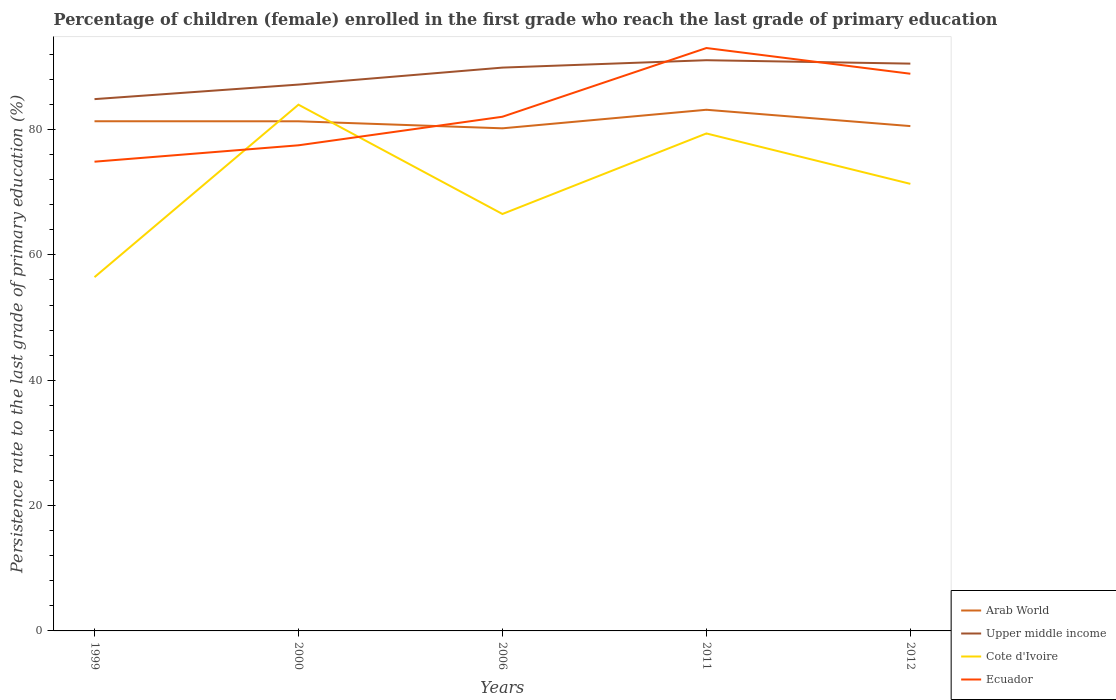How many different coloured lines are there?
Offer a terse response. 4. Does the line corresponding to Ecuador intersect with the line corresponding to Upper middle income?
Give a very brief answer. Yes. Is the number of lines equal to the number of legend labels?
Your answer should be very brief. Yes. Across all years, what is the maximum persistence rate of children in Arab World?
Give a very brief answer. 80.2. What is the total persistence rate of children in Cote d'Ivoire in the graph?
Your response must be concise. -14.88. What is the difference between the highest and the second highest persistence rate of children in Cote d'Ivoire?
Provide a short and direct response. 27.52. What is the difference between the highest and the lowest persistence rate of children in Ecuador?
Provide a short and direct response. 2. Is the persistence rate of children in Ecuador strictly greater than the persistence rate of children in Upper middle income over the years?
Keep it short and to the point. No. How many years are there in the graph?
Make the answer very short. 5. What is the difference between two consecutive major ticks on the Y-axis?
Offer a very short reply. 20. Are the values on the major ticks of Y-axis written in scientific E-notation?
Your answer should be compact. No. Does the graph contain grids?
Your answer should be compact. No. Where does the legend appear in the graph?
Give a very brief answer. Bottom right. What is the title of the graph?
Offer a very short reply. Percentage of children (female) enrolled in the first grade who reach the last grade of primary education. Does "Vietnam" appear as one of the legend labels in the graph?
Your answer should be compact. No. What is the label or title of the Y-axis?
Offer a terse response. Persistence rate to the last grade of primary education (%). What is the Persistence rate to the last grade of primary education (%) in Arab World in 1999?
Give a very brief answer. 81.32. What is the Persistence rate to the last grade of primary education (%) of Upper middle income in 1999?
Provide a short and direct response. 84.86. What is the Persistence rate to the last grade of primary education (%) in Cote d'Ivoire in 1999?
Offer a terse response. 56.45. What is the Persistence rate to the last grade of primary education (%) of Ecuador in 1999?
Ensure brevity in your answer.  74.87. What is the Persistence rate to the last grade of primary education (%) of Arab World in 2000?
Provide a short and direct response. 81.32. What is the Persistence rate to the last grade of primary education (%) in Upper middle income in 2000?
Your answer should be compact. 87.18. What is the Persistence rate to the last grade of primary education (%) in Cote d'Ivoire in 2000?
Keep it short and to the point. 83.97. What is the Persistence rate to the last grade of primary education (%) of Ecuador in 2000?
Provide a succinct answer. 77.49. What is the Persistence rate to the last grade of primary education (%) in Arab World in 2006?
Offer a very short reply. 80.2. What is the Persistence rate to the last grade of primary education (%) of Upper middle income in 2006?
Keep it short and to the point. 89.88. What is the Persistence rate to the last grade of primary education (%) in Cote d'Ivoire in 2006?
Provide a short and direct response. 66.53. What is the Persistence rate to the last grade of primary education (%) in Ecuador in 2006?
Give a very brief answer. 82.04. What is the Persistence rate to the last grade of primary education (%) in Arab World in 2011?
Give a very brief answer. 83.16. What is the Persistence rate to the last grade of primary education (%) of Upper middle income in 2011?
Offer a terse response. 91.06. What is the Persistence rate to the last grade of primary education (%) of Cote d'Ivoire in 2011?
Provide a short and direct response. 79.38. What is the Persistence rate to the last grade of primary education (%) of Ecuador in 2011?
Provide a succinct answer. 93.01. What is the Persistence rate to the last grade of primary education (%) of Arab World in 2012?
Your answer should be compact. 80.55. What is the Persistence rate to the last grade of primary education (%) of Upper middle income in 2012?
Offer a very short reply. 90.52. What is the Persistence rate to the last grade of primary education (%) of Cote d'Ivoire in 2012?
Ensure brevity in your answer.  71.33. What is the Persistence rate to the last grade of primary education (%) of Ecuador in 2012?
Your answer should be very brief. 88.91. Across all years, what is the maximum Persistence rate to the last grade of primary education (%) of Arab World?
Keep it short and to the point. 83.16. Across all years, what is the maximum Persistence rate to the last grade of primary education (%) in Upper middle income?
Provide a succinct answer. 91.06. Across all years, what is the maximum Persistence rate to the last grade of primary education (%) in Cote d'Ivoire?
Your answer should be very brief. 83.97. Across all years, what is the maximum Persistence rate to the last grade of primary education (%) in Ecuador?
Offer a terse response. 93.01. Across all years, what is the minimum Persistence rate to the last grade of primary education (%) of Arab World?
Your answer should be very brief. 80.2. Across all years, what is the minimum Persistence rate to the last grade of primary education (%) in Upper middle income?
Your answer should be compact. 84.86. Across all years, what is the minimum Persistence rate to the last grade of primary education (%) in Cote d'Ivoire?
Make the answer very short. 56.45. Across all years, what is the minimum Persistence rate to the last grade of primary education (%) of Ecuador?
Your answer should be very brief. 74.87. What is the total Persistence rate to the last grade of primary education (%) of Arab World in the graph?
Offer a terse response. 406.55. What is the total Persistence rate to the last grade of primary education (%) in Upper middle income in the graph?
Provide a short and direct response. 443.5. What is the total Persistence rate to the last grade of primary education (%) of Cote d'Ivoire in the graph?
Your answer should be compact. 357.65. What is the total Persistence rate to the last grade of primary education (%) of Ecuador in the graph?
Your response must be concise. 416.32. What is the difference between the Persistence rate to the last grade of primary education (%) of Arab World in 1999 and that in 2000?
Offer a very short reply. 0.01. What is the difference between the Persistence rate to the last grade of primary education (%) in Upper middle income in 1999 and that in 2000?
Give a very brief answer. -2.32. What is the difference between the Persistence rate to the last grade of primary education (%) of Cote d'Ivoire in 1999 and that in 2000?
Provide a succinct answer. -27.52. What is the difference between the Persistence rate to the last grade of primary education (%) in Ecuador in 1999 and that in 2000?
Ensure brevity in your answer.  -2.62. What is the difference between the Persistence rate to the last grade of primary education (%) in Arab World in 1999 and that in 2006?
Your answer should be very brief. 1.13. What is the difference between the Persistence rate to the last grade of primary education (%) of Upper middle income in 1999 and that in 2006?
Provide a short and direct response. -5.03. What is the difference between the Persistence rate to the last grade of primary education (%) of Cote d'Ivoire in 1999 and that in 2006?
Provide a succinct answer. -10.08. What is the difference between the Persistence rate to the last grade of primary education (%) of Ecuador in 1999 and that in 2006?
Offer a very short reply. -7.17. What is the difference between the Persistence rate to the last grade of primary education (%) in Arab World in 1999 and that in 2011?
Give a very brief answer. -1.83. What is the difference between the Persistence rate to the last grade of primary education (%) of Upper middle income in 1999 and that in 2011?
Ensure brevity in your answer.  -6.21. What is the difference between the Persistence rate to the last grade of primary education (%) in Cote d'Ivoire in 1999 and that in 2011?
Provide a short and direct response. -22.93. What is the difference between the Persistence rate to the last grade of primary education (%) of Ecuador in 1999 and that in 2011?
Keep it short and to the point. -18.14. What is the difference between the Persistence rate to the last grade of primary education (%) of Arab World in 1999 and that in 2012?
Keep it short and to the point. 0.77. What is the difference between the Persistence rate to the last grade of primary education (%) of Upper middle income in 1999 and that in 2012?
Your answer should be very brief. -5.66. What is the difference between the Persistence rate to the last grade of primary education (%) in Cote d'Ivoire in 1999 and that in 2012?
Provide a short and direct response. -14.88. What is the difference between the Persistence rate to the last grade of primary education (%) of Ecuador in 1999 and that in 2012?
Make the answer very short. -14.03. What is the difference between the Persistence rate to the last grade of primary education (%) of Arab World in 2000 and that in 2006?
Offer a terse response. 1.12. What is the difference between the Persistence rate to the last grade of primary education (%) of Upper middle income in 2000 and that in 2006?
Make the answer very short. -2.71. What is the difference between the Persistence rate to the last grade of primary education (%) in Cote d'Ivoire in 2000 and that in 2006?
Keep it short and to the point. 17.44. What is the difference between the Persistence rate to the last grade of primary education (%) in Ecuador in 2000 and that in 2006?
Offer a very short reply. -4.56. What is the difference between the Persistence rate to the last grade of primary education (%) of Arab World in 2000 and that in 2011?
Provide a succinct answer. -1.84. What is the difference between the Persistence rate to the last grade of primary education (%) of Upper middle income in 2000 and that in 2011?
Your response must be concise. -3.89. What is the difference between the Persistence rate to the last grade of primary education (%) of Cote d'Ivoire in 2000 and that in 2011?
Your answer should be compact. 4.59. What is the difference between the Persistence rate to the last grade of primary education (%) of Ecuador in 2000 and that in 2011?
Provide a short and direct response. -15.52. What is the difference between the Persistence rate to the last grade of primary education (%) of Arab World in 2000 and that in 2012?
Keep it short and to the point. 0.76. What is the difference between the Persistence rate to the last grade of primary education (%) in Upper middle income in 2000 and that in 2012?
Provide a succinct answer. -3.34. What is the difference between the Persistence rate to the last grade of primary education (%) of Cote d'Ivoire in 2000 and that in 2012?
Provide a succinct answer. 12.64. What is the difference between the Persistence rate to the last grade of primary education (%) in Ecuador in 2000 and that in 2012?
Your answer should be very brief. -11.42. What is the difference between the Persistence rate to the last grade of primary education (%) in Arab World in 2006 and that in 2011?
Provide a short and direct response. -2.96. What is the difference between the Persistence rate to the last grade of primary education (%) of Upper middle income in 2006 and that in 2011?
Your answer should be very brief. -1.18. What is the difference between the Persistence rate to the last grade of primary education (%) in Cote d'Ivoire in 2006 and that in 2011?
Your answer should be compact. -12.85. What is the difference between the Persistence rate to the last grade of primary education (%) of Ecuador in 2006 and that in 2011?
Provide a succinct answer. -10.96. What is the difference between the Persistence rate to the last grade of primary education (%) of Arab World in 2006 and that in 2012?
Your answer should be very brief. -0.36. What is the difference between the Persistence rate to the last grade of primary education (%) in Upper middle income in 2006 and that in 2012?
Your answer should be very brief. -0.63. What is the difference between the Persistence rate to the last grade of primary education (%) in Cote d'Ivoire in 2006 and that in 2012?
Your answer should be compact. -4.81. What is the difference between the Persistence rate to the last grade of primary education (%) in Ecuador in 2006 and that in 2012?
Your response must be concise. -6.86. What is the difference between the Persistence rate to the last grade of primary education (%) in Arab World in 2011 and that in 2012?
Your response must be concise. 2.6. What is the difference between the Persistence rate to the last grade of primary education (%) in Upper middle income in 2011 and that in 2012?
Provide a short and direct response. 0.55. What is the difference between the Persistence rate to the last grade of primary education (%) of Cote d'Ivoire in 2011 and that in 2012?
Give a very brief answer. 8.04. What is the difference between the Persistence rate to the last grade of primary education (%) in Ecuador in 2011 and that in 2012?
Provide a short and direct response. 4.1. What is the difference between the Persistence rate to the last grade of primary education (%) of Arab World in 1999 and the Persistence rate to the last grade of primary education (%) of Upper middle income in 2000?
Keep it short and to the point. -5.85. What is the difference between the Persistence rate to the last grade of primary education (%) in Arab World in 1999 and the Persistence rate to the last grade of primary education (%) in Cote d'Ivoire in 2000?
Provide a succinct answer. -2.65. What is the difference between the Persistence rate to the last grade of primary education (%) in Arab World in 1999 and the Persistence rate to the last grade of primary education (%) in Ecuador in 2000?
Your answer should be compact. 3.84. What is the difference between the Persistence rate to the last grade of primary education (%) of Upper middle income in 1999 and the Persistence rate to the last grade of primary education (%) of Cote d'Ivoire in 2000?
Provide a succinct answer. 0.89. What is the difference between the Persistence rate to the last grade of primary education (%) in Upper middle income in 1999 and the Persistence rate to the last grade of primary education (%) in Ecuador in 2000?
Your answer should be compact. 7.37. What is the difference between the Persistence rate to the last grade of primary education (%) in Cote d'Ivoire in 1999 and the Persistence rate to the last grade of primary education (%) in Ecuador in 2000?
Your answer should be compact. -21.04. What is the difference between the Persistence rate to the last grade of primary education (%) of Arab World in 1999 and the Persistence rate to the last grade of primary education (%) of Upper middle income in 2006?
Make the answer very short. -8.56. What is the difference between the Persistence rate to the last grade of primary education (%) of Arab World in 1999 and the Persistence rate to the last grade of primary education (%) of Cote d'Ivoire in 2006?
Provide a succinct answer. 14.8. What is the difference between the Persistence rate to the last grade of primary education (%) in Arab World in 1999 and the Persistence rate to the last grade of primary education (%) in Ecuador in 2006?
Ensure brevity in your answer.  -0.72. What is the difference between the Persistence rate to the last grade of primary education (%) in Upper middle income in 1999 and the Persistence rate to the last grade of primary education (%) in Cote d'Ivoire in 2006?
Ensure brevity in your answer.  18.33. What is the difference between the Persistence rate to the last grade of primary education (%) in Upper middle income in 1999 and the Persistence rate to the last grade of primary education (%) in Ecuador in 2006?
Your response must be concise. 2.81. What is the difference between the Persistence rate to the last grade of primary education (%) in Cote d'Ivoire in 1999 and the Persistence rate to the last grade of primary education (%) in Ecuador in 2006?
Offer a very short reply. -25.59. What is the difference between the Persistence rate to the last grade of primary education (%) in Arab World in 1999 and the Persistence rate to the last grade of primary education (%) in Upper middle income in 2011?
Offer a very short reply. -9.74. What is the difference between the Persistence rate to the last grade of primary education (%) of Arab World in 1999 and the Persistence rate to the last grade of primary education (%) of Cote d'Ivoire in 2011?
Offer a terse response. 1.95. What is the difference between the Persistence rate to the last grade of primary education (%) in Arab World in 1999 and the Persistence rate to the last grade of primary education (%) in Ecuador in 2011?
Ensure brevity in your answer.  -11.68. What is the difference between the Persistence rate to the last grade of primary education (%) of Upper middle income in 1999 and the Persistence rate to the last grade of primary education (%) of Cote d'Ivoire in 2011?
Your answer should be compact. 5.48. What is the difference between the Persistence rate to the last grade of primary education (%) in Upper middle income in 1999 and the Persistence rate to the last grade of primary education (%) in Ecuador in 2011?
Make the answer very short. -8.15. What is the difference between the Persistence rate to the last grade of primary education (%) of Cote d'Ivoire in 1999 and the Persistence rate to the last grade of primary education (%) of Ecuador in 2011?
Keep it short and to the point. -36.56. What is the difference between the Persistence rate to the last grade of primary education (%) of Arab World in 1999 and the Persistence rate to the last grade of primary education (%) of Upper middle income in 2012?
Provide a succinct answer. -9.19. What is the difference between the Persistence rate to the last grade of primary education (%) of Arab World in 1999 and the Persistence rate to the last grade of primary education (%) of Cote d'Ivoire in 2012?
Offer a terse response. 9.99. What is the difference between the Persistence rate to the last grade of primary education (%) of Arab World in 1999 and the Persistence rate to the last grade of primary education (%) of Ecuador in 2012?
Your answer should be very brief. -7.58. What is the difference between the Persistence rate to the last grade of primary education (%) of Upper middle income in 1999 and the Persistence rate to the last grade of primary education (%) of Cote d'Ivoire in 2012?
Offer a terse response. 13.52. What is the difference between the Persistence rate to the last grade of primary education (%) of Upper middle income in 1999 and the Persistence rate to the last grade of primary education (%) of Ecuador in 2012?
Provide a succinct answer. -4.05. What is the difference between the Persistence rate to the last grade of primary education (%) of Cote d'Ivoire in 1999 and the Persistence rate to the last grade of primary education (%) of Ecuador in 2012?
Offer a very short reply. -32.46. What is the difference between the Persistence rate to the last grade of primary education (%) in Arab World in 2000 and the Persistence rate to the last grade of primary education (%) in Upper middle income in 2006?
Your answer should be compact. -8.57. What is the difference between the Persistence rate to the last grade of primary education (%) in Arab World in 2000 and the Persistence rate to the last grade of primary education (%) in Cote d'Ivoire in 2006?
Your answer should be very brief. 14.79. What is the difference between the Persistence rate to the last grade of primary education (%) of Arab World in 2000 and the Persistence rate to the last grade of primary education (%) of Ecuador in 2006?
Make the answer very short. -0.73. What is the difference between the Persistence rate to the last grade of primary education (%) in Upper middle income in 2000 and the Persistence rate to the last grade of primary education (%) in Cote d'Ivoire in 2006?
Offer a terse response. 20.65. What is the difference between the Persistence rate to the last grade of primary education (%) in Upper middle income in 2000 and the Persistence rate to the last grade of primary education (%) in Ecuador in 2006?
Ensure brevity in your answer.  5.13. What is the difference between the Persistence rate to the last grade of primary education (%) in Cote d'Ivoire in 2000 and the Persistence rate to the last grade of primary education (%) in Ecuador in 2006?
Your answer should be compact. 1.93. What is the difference between the Persistence rate to the last grade of primary education (%) in Arab World in 2000 and the Persistence rate to the last grade of primary education (%) in Upper middle income in 2011?
Your response must be concise. -9.75. What is the difference between the Persistence rate to the last grade of primary education (%) of Arab World in 2000 and the Persistence rate to the last grade of primary education (%) of Cote d'Ivoire in 2011?
Provide a succinct answer. 1.94. What is the difference between the Persistence rate to the last grade of primary education (%) in Arab World in 2000 and the Persistence rate to the last grade of primary education (%) in Ecuador in 2011?
Make the answer very short. -11.69. What is the difference between the Persistence rate to the last grade of primary education (%) in Upper middle income in 2000 and the Persistence rate to the last grade of primary education (%) in Cote d'Ivoire in 2011?
Keep it short and to the point. 7.8. What is the difference between the Persistence rate to the last grade of primary education (%) in Upper middle income in 2000 and the Persistence rate to the last grade of primary education (%) in Ecuador in 2011?
Ensure brevity in your answer.  -5.83. What is the difference between the Persistence rate to the last grade of primary education (%) in Cote d'Ivoire in 2000 and the Persistence rate to the last grade of primary education (%) in Ecuador in 2011?
Offer a very short reply. -9.04. What is the difference between the Persistence rate to the last grade of primary education (%) of Arab World in 2000 and the Persistence rate to the last grade of primary education (%) of Upper middle income in 2012?
Make the answer very short. -9.2. What is the difference between the Persistence rate to the last grade of primary education (%) in Arab World in 2000 and the Persistence rate to the last grade of primary education (%) in Cote d'Ivoire in 2012?
Make the answer very short. 9.98. What is the difference between the Persistence rate to the last grade of primary education (%) in Arab World in 2000 and the Persistence rate to the last grade of primary education (%) in Ecuador in 2012?
Provide a succinct answer. -7.59. What is the difference between the Persistence rate to the last grade of primary education (%) in Upper middle income in 2000 and the Persistence rate to the last grade of primary education (%) in Cote d'Ivoire in 2012?
Offer a terse response. 15.84. What is the difference between the Persistence rate to the last grade of primary education (%) of Upper middle income in 2000 and the Persistence rate to the last grade of primary education (%) of Ecuador in 2012?
Give a very brief answer. -1.73. What is the difference between the Persistence rate to the last grade of primary education (%) in Cote d'Ivoire in 2000 and the Persistence rate to the last grade of primary education (%) in Ecuador in 2012?
Your answer should be compact. -4.94. What is the difference between the Persistence rate to the last grade of primary education (%) in Arab World in 2006 and the Persistence rate to the last grade of primary education (%) in Upper middle income in 2011?
Provide a short and direct response. -10.87. What is the difference between the Persistence rate to the last grade of primary education (%) of Arab World in 2006 and the Persistence rate to the last grade of primary education (%) of Cote d'Ivoire in 2011?
Your answer should be compact. 0.82. What is the difference between the Persistence rate to the last grade of primary education (%) of Arab World in 2006 and the Persistence rate to the last grade of primary education (%) of Ecuador in 2011?
Offer a terse response. -12.81. What is the difference between the Persistence rate to the last grade of primary education (%) of Upper middle income in 2006 and the Persistence rate to the last grade of primary education (%) of Cote d'Ivoire in 2011?
Provide a short and direct response. 10.51. What is the difference between the Persistence rate to the last grade of primary education (%) of Upper middle income in 2006 and the Persistence rate to the last grade of primary education (%) of Ecuador in 2011?
Provide a succinct answer. -3.12. What is the difference between the Persistence rate to the last grade of primary education (%) in Cote d'Ivoire in 2006 and the Persistence rate to the last grade of primary education (%) in Ecuador in 2011?
Give a very brief answer. -26.48. What is the difference between the Persistence rate to the last grade of primary education (%) of Arab World in 2006 and the Persistence rate to the last grade of primary education (%) of Upper middle income in 2012?
Offer a very short reply. -10.32. What is the difference between the Persistence rate to the last grade of primary education (%) of Arab World in 2006 and the Persistence rate to the last grade of primary education (%) of Cote d'Ivoire in 2012?
Your response must be concise. 8.86. What is the difference between the Persistence rate to the last grade of primary education (%) of Arab World in 2006 and the Persistence rate to the last grade of primary education (%) of Ecuador in 2012?
Provide a short and direct response. -8.71. What is the difference between the Persistence rate to the last grade of primary education (%) of Upper middle income in 2006 and the Persistence rate to the last grade of primary education (%) of Cote d'Ivoire in 2012?
Ensure brevity in your answer.  18.55. What is the difference between the Persistence rate to the last grade of primary education (%) of Upper middle income in 2006 and the Persistence rate to the last grade of primary education (%) of Ecuador in 2012?
Your answer should be compact. 0.98. What is the difference between the Persistence rate to the last grade of primary education (%) in Cote d'Ivoire in 2006 and the Persistence rate to the last grade of primary education (%) in Ecuador in 2012?
Give a very brief answer. -22.38. What is the difference between the Persistence rate to the last grade of primary education (%) of Arab World in 2011 and the Persistence rate to the last grade of primary education (%) of Upper middle income in 2012?
Keep it short and to the point. -7.36. What is the difference between the Persistence rate to the last grade of primary education (%) of Arab World in 2011 and the Persistence rate to the last grade of primary education (%) of Cote d'Ivoire in 2012?
Your answer should be very brief. 11.82. What is the difference between the Persistence rate to the last grade of primary education (%) in Arab World in 2011 and the Persistence rate to the last grade of primary education (%) in Ecuador in 2012?
Give a very brief answer. -5.75. What is the difference between the Persistence rate to the last grade of primary education (%) in Upper middle income in 2011 and the Persistence rate to the last grade of primary education (%) in Cote d'Ivoire in 2012?
Offer a very short reply. 19.73. What is the difference between the Persistence rate to the last grade of primary education (%) in Upper middle income in 2011 and the Persistence rate to the last grade of primary education (%) in Ecuador in 2012?
Make the answer very short. 2.16. What is the difference between the Persistence rate to the last grade of primary education (%) in Cote d'Ivoire in 2011 and the Persistence rate to the last grade of primary education (%) in Ecuador in 2012?
Offer a very short reply. -9.53. What is the average Persistence rate to the last grade of primary education (%) of Arab World per year?
Offer a terse response. 81.31. What is the average Persistence rate to the last grade of primary education (%) of Upper middle income per year?
Your answer should be compact. 88.7. What is the average Persistence rate to the last grade of primary education (%) of Cote d'Ivoire per year?
Your answer should be compact. 71.53. What is the average Persistence rate to the last grade of primary education (%) in Ecuador per year?
Keep it short and to the point. 83.26. In the year 1999, what is the difference between the Persistence rate to the last grade of primary education (%) in Arab World and Persistence rate to the last grade of primary education (%) in Upper middle income?
Your answer should be very brief. -3.53. In the year 1999, what is the difference between the Persistence rate to the last grade of primary education (%) in Arab World and Persistence rate to the last grade of primary education (%) in Cote d'Ivoire?
Provide a short and direct response. 24.87. In the year 1999, what is the difference between the Persistence rate to the last grade of primary education (%) in Arab World and Persistence rate to the last grade of primary education (%) in Ecuador?
Your response must be concise. 6.45. In the year 1999, what is the difference between the Persistence rate to the last grade of primary education (%) of Upper middle income and Persistence rate to the last grade of primary education (%) of Cote d'Ivoire?
Make the answer very short. 28.41. In the year 1999, what is the difference between the Persistence rate to the last grade of primary education (%) in Upper middle income and Persistence rate to the last grade of primary education (%) in Ecuador?
Your response must be concise. 9.98. In the year 1999, what is the difference between the Persistence rate to the last grade of primary education (%) in Cote d'Ivoire and Persistence rate to the last grade of primary education (%) in Ecuador?
Your answer should be compact. -18.42. In the year 2000, what is the difference between the Persistence rate to the last grade of primary education (%) of Arab World and Persistence rate to the last grade of primary education (%) of Upper middle income?
Your response must be concise. -5.86. In the year 2000, what is the difference between the Persistence rate to the last grade of primary education (%) in Arab World and Persistence rate to the last grade of primary education (%) in Cote d'Ivoire?
Your answer should be compact. -2.65. In the year 2000, what is the difference between the Persistence rate to the last grade of primary education (%) in Arab World and Persistence rate to the last grade of primary education (%) in Ecuador?
Offer a very short reply. 3.83. In the year 2000, what is the difference between the Persistence rate to the last grade of primary education (%) of Upper middle income and Persistence rate to the last grade of primary education (%) of Cote d'Ivoire?
Provide a short and direct response. 3.21. In the year 2000, what is the difference between the Persistence rate to the last grade of primary education (%) of Upper middle income and Persistence rate to the last grade of primary education (%) of Ecuador?
Your answer should be very brief. 9.69. In the year 2000, what is the difference between the Persistence rate to the last grade of primary education (%) of Cote d'Ivoire and Persistence rate to the last grade of primary education (%) of Ecuador?
Provide a succinct answer. 6.48. In the year 2006, what is the difference between the Persistence rate to the last grade of primary education (%) of Arab World and Persistence rate to the last grade of primary education (%) of Upper middle income?
Offer a very short reply. -9.69. In the year 2006, what is the difference between the Persistence rate to the last grade of primary education (%) of Arab World and Persistence rate to the last grade of primary education (%) of Cote d'Ivoire?
Provide a short and direct response. 13.67. In the year 2006, what is the difference between the Persistence rate to the last grade of primary education (%) in Arab World and Persistence rate to the last grade of primary education (%) in Ecuador?
Your answer should be very brief. -1.85. In the year 2006, what is the difference between the Persistence rate to the last grade of primary education (%) of Upper middle income and Persistence rate to the last grade of primary education (%) of Cote d'Ivoire?
Ensure brevity in your answer.  23.36. In the year 2006, what is the difference between the Persistence rate to the last grade of primary education (%) of Upper middle income and Persistence rate to the last grade of primary education (%) of Ecuador?
Make the answer very short. 7.84. In the year 2006, what is the difference between the Persistence rate to the last grade of primary education (%) of Cote d'Ivoire and Persistence rate to the last grade of primary education (%) of Ecuador?
Your response must be concise. -15.52. In the year 2011, what is the difference between the Persistence rate to the last grade of primary education (%) of Arab World and Persistence rate to the last grade of primary education (%) of Upper middle income?
Give a very brief answer. -7.91. In the year 2011, what is the difference between the Persistence rate to the last grade of primary education (%) of Arab World and Persistence rate to the last grade of primary education (%) of Cote d'Ivoire?
Ensure brevity in your answer.  3.78. In the year 2011, what is the difference between the Persistence rate to the last grade of primary education (%) of Arab World and Persistence rate to the last grade of primary education (%) of Ecuador?
Ensure brevity in your answer.  -9.85. In the year 2011, what is the difference between the Persistence rate to the last grade of primary education (%) in Upper middle income and Persistence rate to the last grade of primary education (%) in Cote d'Ivoire?
Your answer should be compact. 11.69. In the year 2011, what is the difference between the Persistence rate to the last grade of primary education (%) of Upper middle income and Persistence rate to the last grade of primary education (%) of Ecuador?
Your answer should be compact. -1.94. In the year 2011, what is the difference between the Persistence rate to the last grade of primary education (%) in Cote d'Ivoire and Persistence rate to the last grade of primary education (%) in Ecuador?
Offer a very short reply. -13.63. In the year 2012, what is the difference between the Persistence rate to the last grade of primary education (%) in Arab World and Persistence rate to the last grade of primary education (%) in Upper middle income?
Provide a succinct answer. -9.97. In the year 2012, what is the difference between the Persistence rate to the last grade of primary education (%) in Arab World and Persistence rate to the last grade of primary education (%) in Cote d'Ivoire?
Your answer should be compact. 9.22. In the year 2012, what is the difference between the Persistence rate to the last grade of primary education (%) of Arab World and Persistence rate to the last grade of primary education (%) of Ecuador?
Offer a very short reply. -8.35. In the year 2012, what is the difference between the Persistence rate to the last grade of primary education (%) in Upper middle income and Persistence rate to the last grade of primary education (%) in Cote d'Ivoire?
Keep it short and to the point. 19.18. In the year 2012, what is the difference between the Persistence rate to the last grade of primary education (%) of Upper middle income and Persistence rate to the last grade of primary education (%) of Ecuador?
Provide a short and direct response. 1.61. In the year 2012, what is the difference between the Persistence rate to the last grade of primary education (%) of Cote d'Ivoire and Persistence rate to the last grade of primary education (%) of Ecuador?
Provide a short and direct response. -17.57. What is the ratio of the Persistence rate to the last grade of primary education (%) of Upper middle income in 1999 to that in 2000?
Provide a short and direct response. 0.97. What is the ratio of the Persistence rate to the last grade of primary education (%) of Cote d'Ivoire in 1999 to that in 2000?
Your response must be concise. 0.67. What is the ratio of the Persistence rate to the last grade of primary education (%) of Ecuador in 1999 to that in 2000?
Your response must be concise. 0.97. What is the ratio of the Persistence rate to the last grade of primary education (%) in Arab World in 1999 to that in 2006?
Offer a terse response. 1.01. What is the ratio of the Persistence rate to the last grade of primary education (%) in Upper middle income in 1999 to that in 2006?
Provide a short and direct response. 0.94. What is the ratio of the Persistence rate to the last grade of primary education (%) in Cote d'Ivoire in 1999 to that in 2006?
Give a very brief answer. 0.85. What is the ratio of the Persistence rate to the last grade of primary education (%) in Ecuador in 1999 to that in 2006?
Provide a short and direct response. 0.91. What is the ratio of the Persistence rate to the last grade of primary education (%) in Arab World in 1999 to that in 2011?
Offer a terse response. 0.98. What is the ratio of the Persistence rate to the last grade of primary education (%) in Upper middle income in 1999 to that in 2011?
Give a very brief answer. 0.93. What is the ratio of the Persistence rate to the last grade of primary education (%) in Cote d'Ivoire in 1999 to that in 2011?
Ensure brevity in your answer.  0.71. What is the ratio of the Persistence rate to the last grade of primary education (%) in Ecuador in 1999 to that in 2011?
Your answer should be very brief. 0.81. What is the ratio of the Persistence rate to the last grade of primary education (%) of Arab World in 1999 to that in 2012?
Your answer should be compact. 1.01. What is the ratio of the Persistence rate to the last grade of primary education (%) of Upper middle income in 1999 to that in 2012?
Make the answer very short. 0.94. What is the ratio of the Persistence rate to the last grade of primary education (%) of Cote d'Ivoire in 1999 to that in 2012?
Provide a succinct answer. 0.79. What is the ratio of the Persistence rate to the last grade of primary education (%) in Ecuador in 1999 to that in 2012?
Give a very brief answer. 0.84. What is the ratio of the Persistence rate to the last grade of primary education (%) in Upper middle income in 2000 to that in 2006?
Offer a terse response. 0.97. What is the ratio of the Persistence rate to the last grade of primary education (%) of Cote d'Ivoire in 2000 to that in 2006?
Provide a short and direct response. 1.26. What is the ratio of the Persistence rate to the last grade of primary education (%) in Ecuador in 2000 to that in 2006?
Give a very brief answer. 0.94. What is the ratio of the Persistence rate to the last grade of primary education (%) in Arab World in 2000 to that in 2011?
Provide a succinct answer. 0.98. What is the ratio of the Persistence rate to the last grade of primary education (%) of Upper middle income in 2000 to that in 2011?
Give a very brief answer. 0.96. What is the ratio of the Persistence rate to the last grade of primary education (%) in Cote d'Ivoire in 2000 to that in 2011?
Offer a terse response. 1.06. What is the ratio of the Persistence rate to the last grade of primary education (%) of Ecuador in 2000 to that in 2011?
Your answer should be very brief. 0.83. What is the ratio of the Persistence rate to the last grade of primary education (%) of Arab World in 2000 to that in 2012?
Ensure brevity in your answer.  1.01. What is the ratio of the Persistence rate to the last grade of primary education (%) in Upper middle income in 2000 to that in 2012?
Keep it short and to the point. 0.96. What is the ratio of the Persistence rate to the last grade of primary education (%) of Cote d'Ivoire in 2000 to that in 2012?
Your answer should be compact. 1.18. What is the ratio of the Persistence rate to the last grade of primary education (%) of Ecuador in 2000 to that in 2012?
Offer a very short reply. 0.87. What is the ratio of the Persistence rate to the last grade of primary education (%) of Arab World in 2006 to that in 2011?
Your answer should be compact. 0.96. What is the ratio of the Persistence rate to the last grade of primary education (%) in Upper middle income in 2006 to that in 2011?
Offer a very short reply. 0.99. What is the ratio of the Persistence rate to the last grade of primary education (%) in Cote d'Ivoire in 2006 to that in 2011?
Provide a succinct answer. 0.84. What is the ratio of the Persistence rate to the last grade of primary education (%) in Ecuador in 2006 to that in 2011?
Provide a succinct answer. 0.88. What is the ratio of the Persistence rate to the last grade of primary education (%) in Upper middle income in 2006 to that in 2012?
Give a very brief answer. 0.99. What is the ratio of the Persistence rate to the last grade of primary education (%) of Cote d'Ivoire in 2006 to that in 2012?
Your answer should be very brief. 0.93. What is the ratio of the Persistence rate to the last grade of primary education (%) of Ecuador in 2006 to that in 2012?
Your answer should be compact. 0.92. What is the ratio of the Persistence rate to the last grade of primary education (%) of Arab World in 2011 to that in 2012?
Ensure brevity in your answer.  1.03. What is the ratio of the Persistence rate to the last grade of primary education (%) in Cote d'Ivoire in 2011 to that in 2012?
Offer a very short reply. 1.11. What is the ratio of the Persistence rate to the last grade of primary education (%) of Ecuador in 2011 to that in 2012?
Keep it short and to the point. 1.05. What is the difference between the highest and the second highest Persistence rate to the last grade of primary education (%) of Arab World?
Keep it short and to the point. 1.83. What is the difference between the highest and the second highest Persistence rate to the last grade of primary education (%) in Upper middle income?
Offer a very short reply. 0.55. What is the difference between the highest and the second highest Persistence rate to the last grade of primary education (%) in Cote d'Ivoire?
Your answer should be very brief. 4.59. What is the difference between the highest and the second highest Persistence rate to the last grade of primary education (%) of Ecuador?
Your response must be concise. 4.1. What is the difference between the highest and the lowest Persistence rate to the last grade of primary education (%) of Arab World?
Provide a succinct answer. 2.96. What is the difference between the highest and the lowest Persistence rate to the last grade of primary education (%) in Upper middle income?
Provide a short and direct response. 6.21. What is the difference between the highest and the lowest Persistence rate to the last grade of primary education (%) in Cote d'Ivoire?
Your answer should be very brief. 27.52. What is the difference between the highest and the lowest Persistence rate to the last grade of primary education (%) of Ecuador?
Provide a short and direct response. 18.14. 